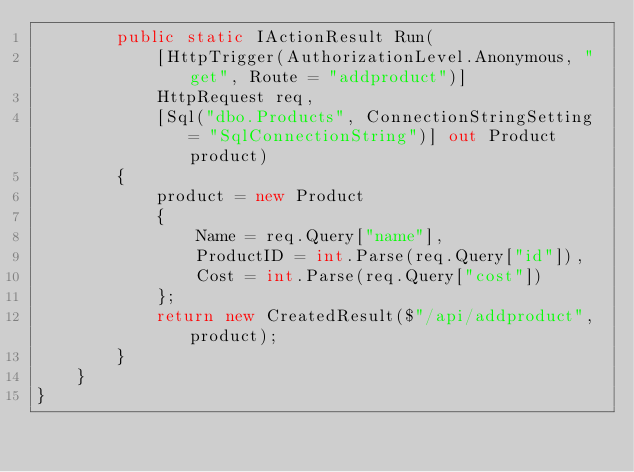Convert code to text. <code><loc_0><loc_0><loc_500><loc_500><_C#_>        public static IActionResult Run(
            [HttpTrigger(AuthorizationLevel.Anonymous, "get", Route = "addproduct")]
            HttpRequest req,
            [Sql("dbo.Products", ConnectionStringSetting = "SqlConnectionString")] out Product product)
        {
            product = new Product
            {
                Name = req.Query["name"],
                ProductID = int.Parse(req.Query["id"]),
                Cost = int.Parse(req.Query["cost"])
            };
            return new CreatedResult($"/api/addproduct", product);
        }
    }
}
</code> 